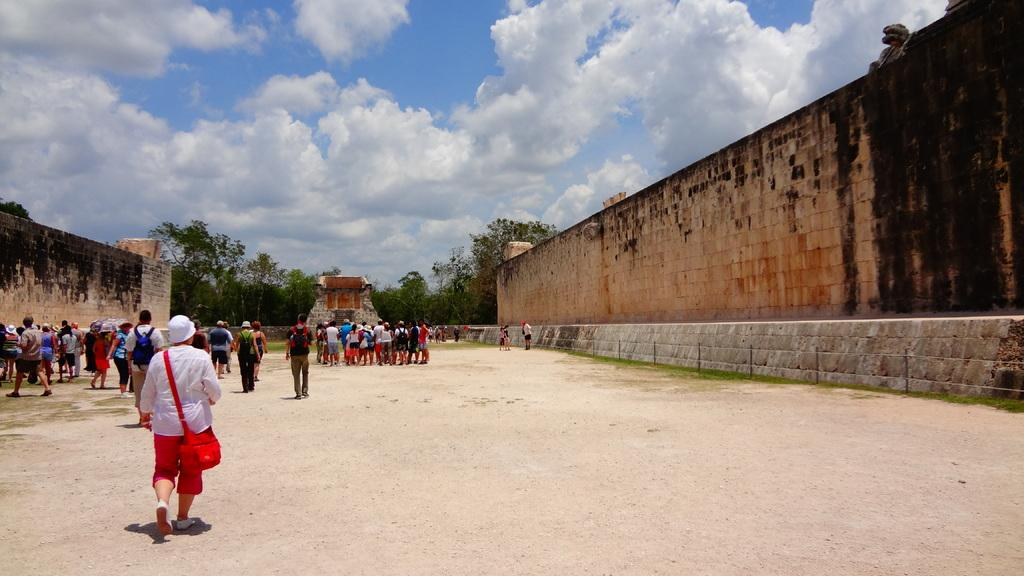What is happening in the image involving a group of people? There is a group of people in the image, but their specific activity is not clear. Can you describe the person who is walking in the image? The person walking in the image is wearing a red color bag. What type of structures can be seen in the image? There are walls in the image. What other natural elements are present in the image? There are trees in the image. What can be seen in the background of the image? The sky is visible in the background of the image, and it has heavy clouds. What type of plantation can be seen in the image? There is no plantation present in the image. Can you describe the cushion that the person is sitting on in the image? There is no cushion present in the image; the person is walking. 